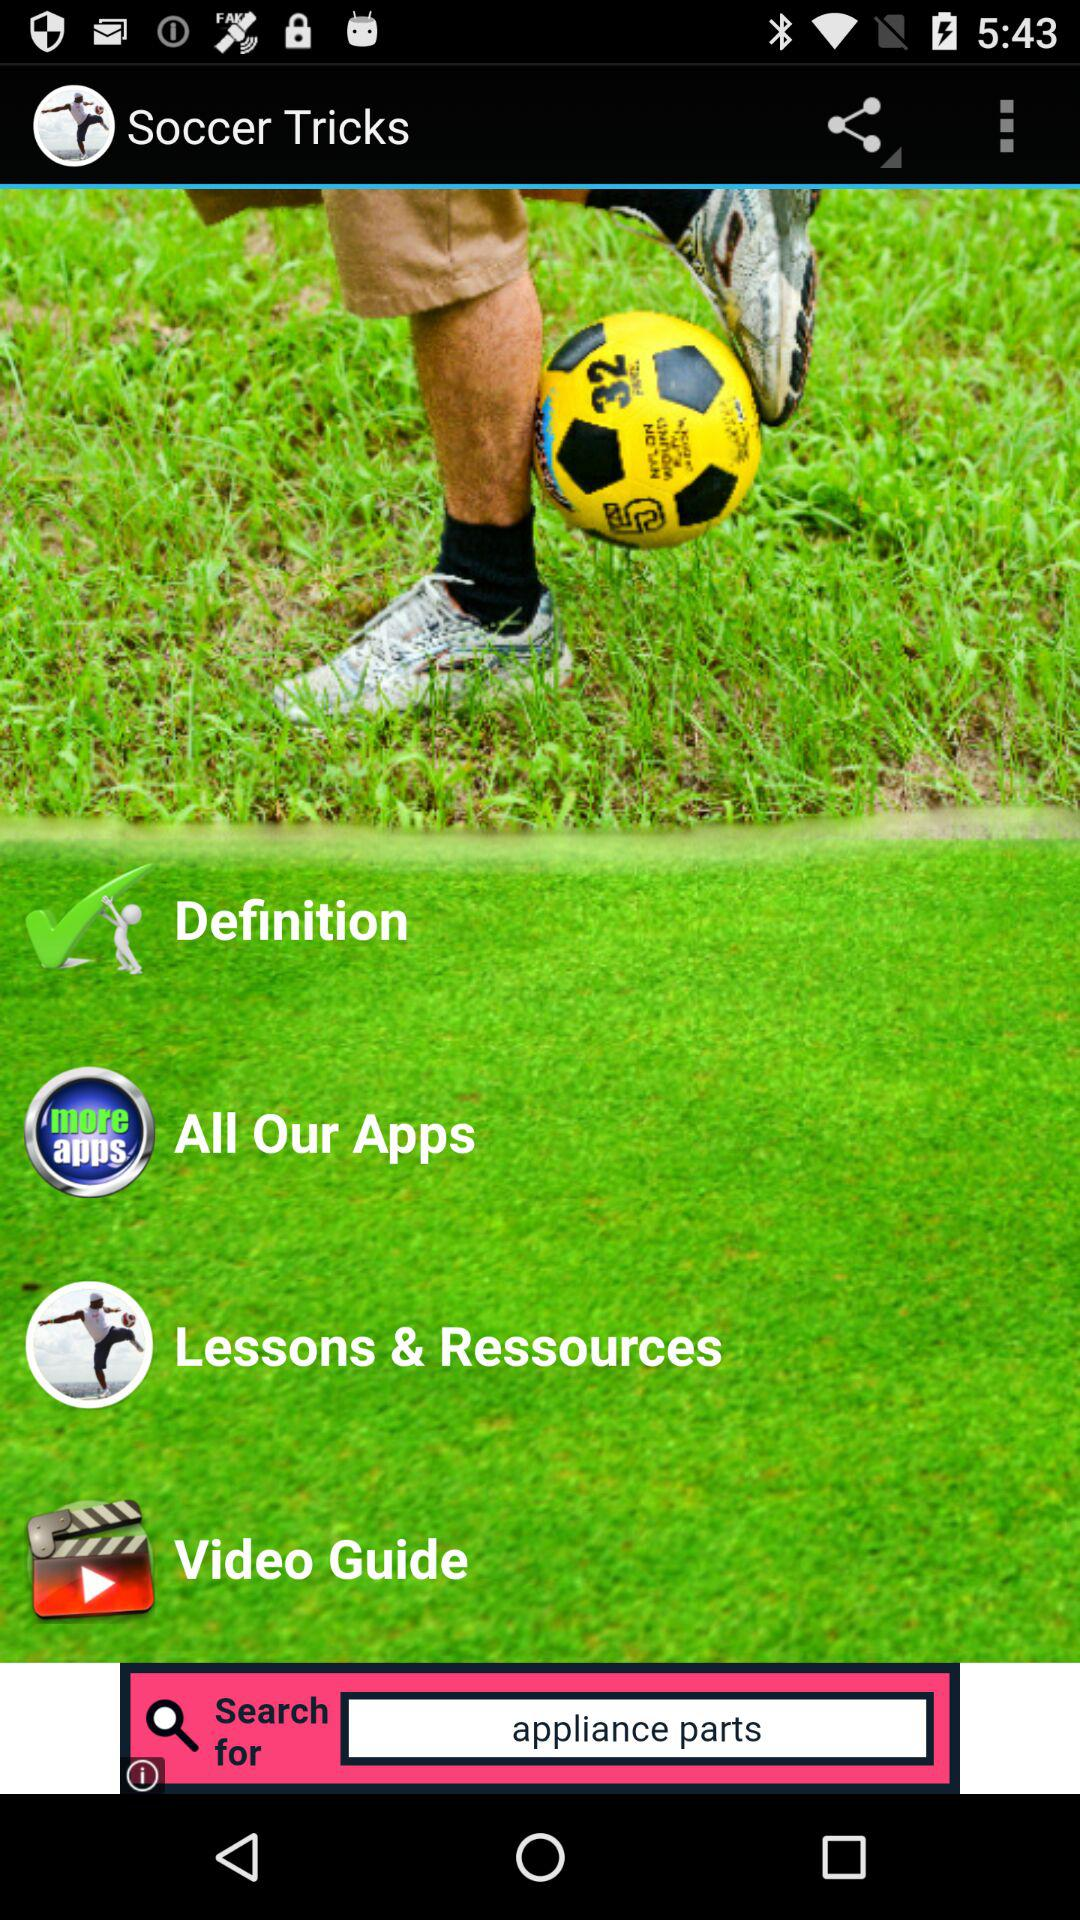What is the app name? The app name is "Soccer Tricks". 